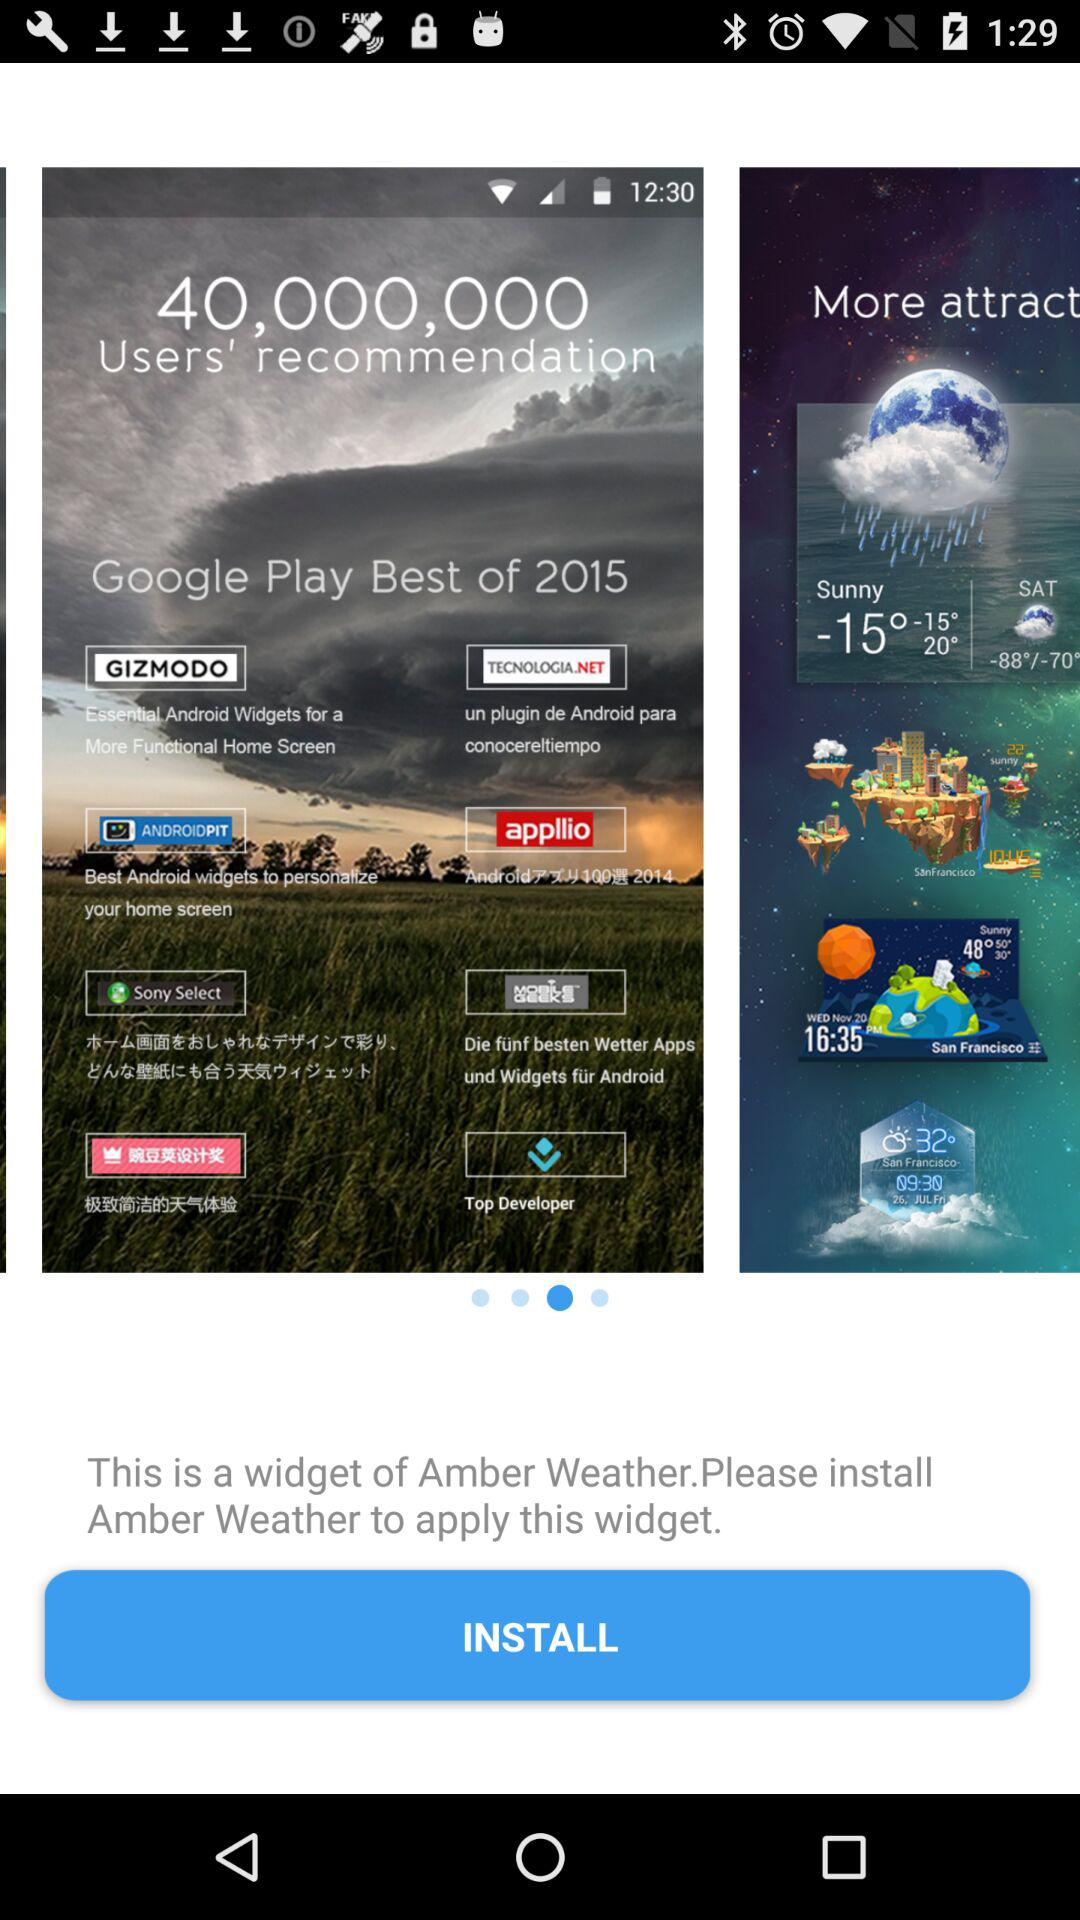How many users' recommendations are there? There are 40,000,000 users' recommendations. 